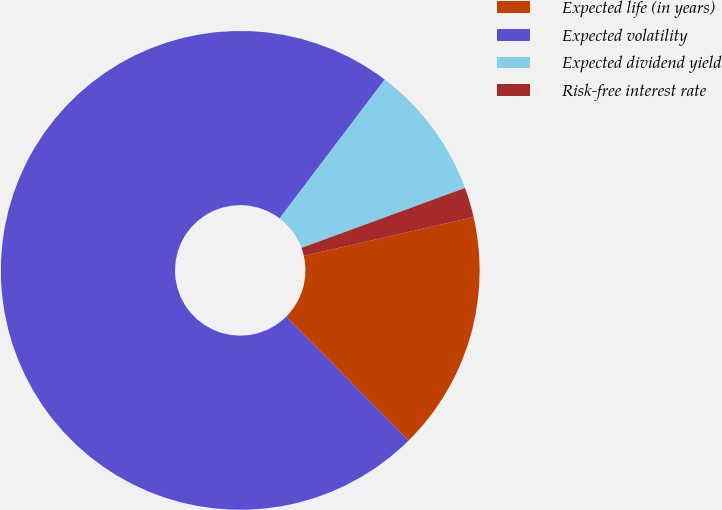Convert chart. <chart><loc_0><loc_0><loc_500><loc_500><pie_chart><fcel>Expected life (in years)<fcel>Expected volatility<fcel>Expected dividend yield<fcel>Risk-free interest rate<nl><fcel>16.16%<fcel>72.73%<fcel>9.09%<fcel>2.02%<nl></chart> 